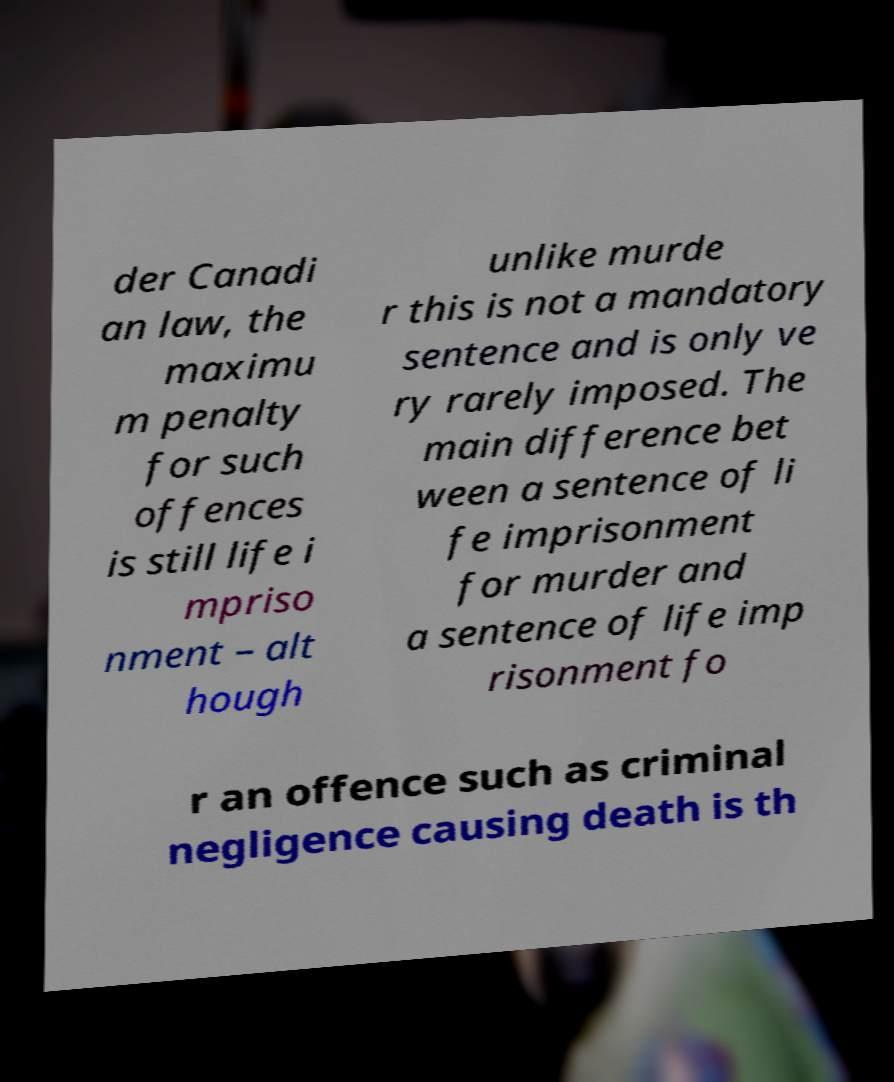Could you assist in decoding the text presented in this image and type it out clearly? der Canadi an law, the maximu m penalty for such offences is still life i mpriso nment – alt hough unlike murde r this is not a mandatory sentence and is only ve ry rarely imposed. The main difference bet ween a sentence of li fe imprisonment for murder and a sentence of life imp risonment fo r an offence such as criminal negligence causing death is th 